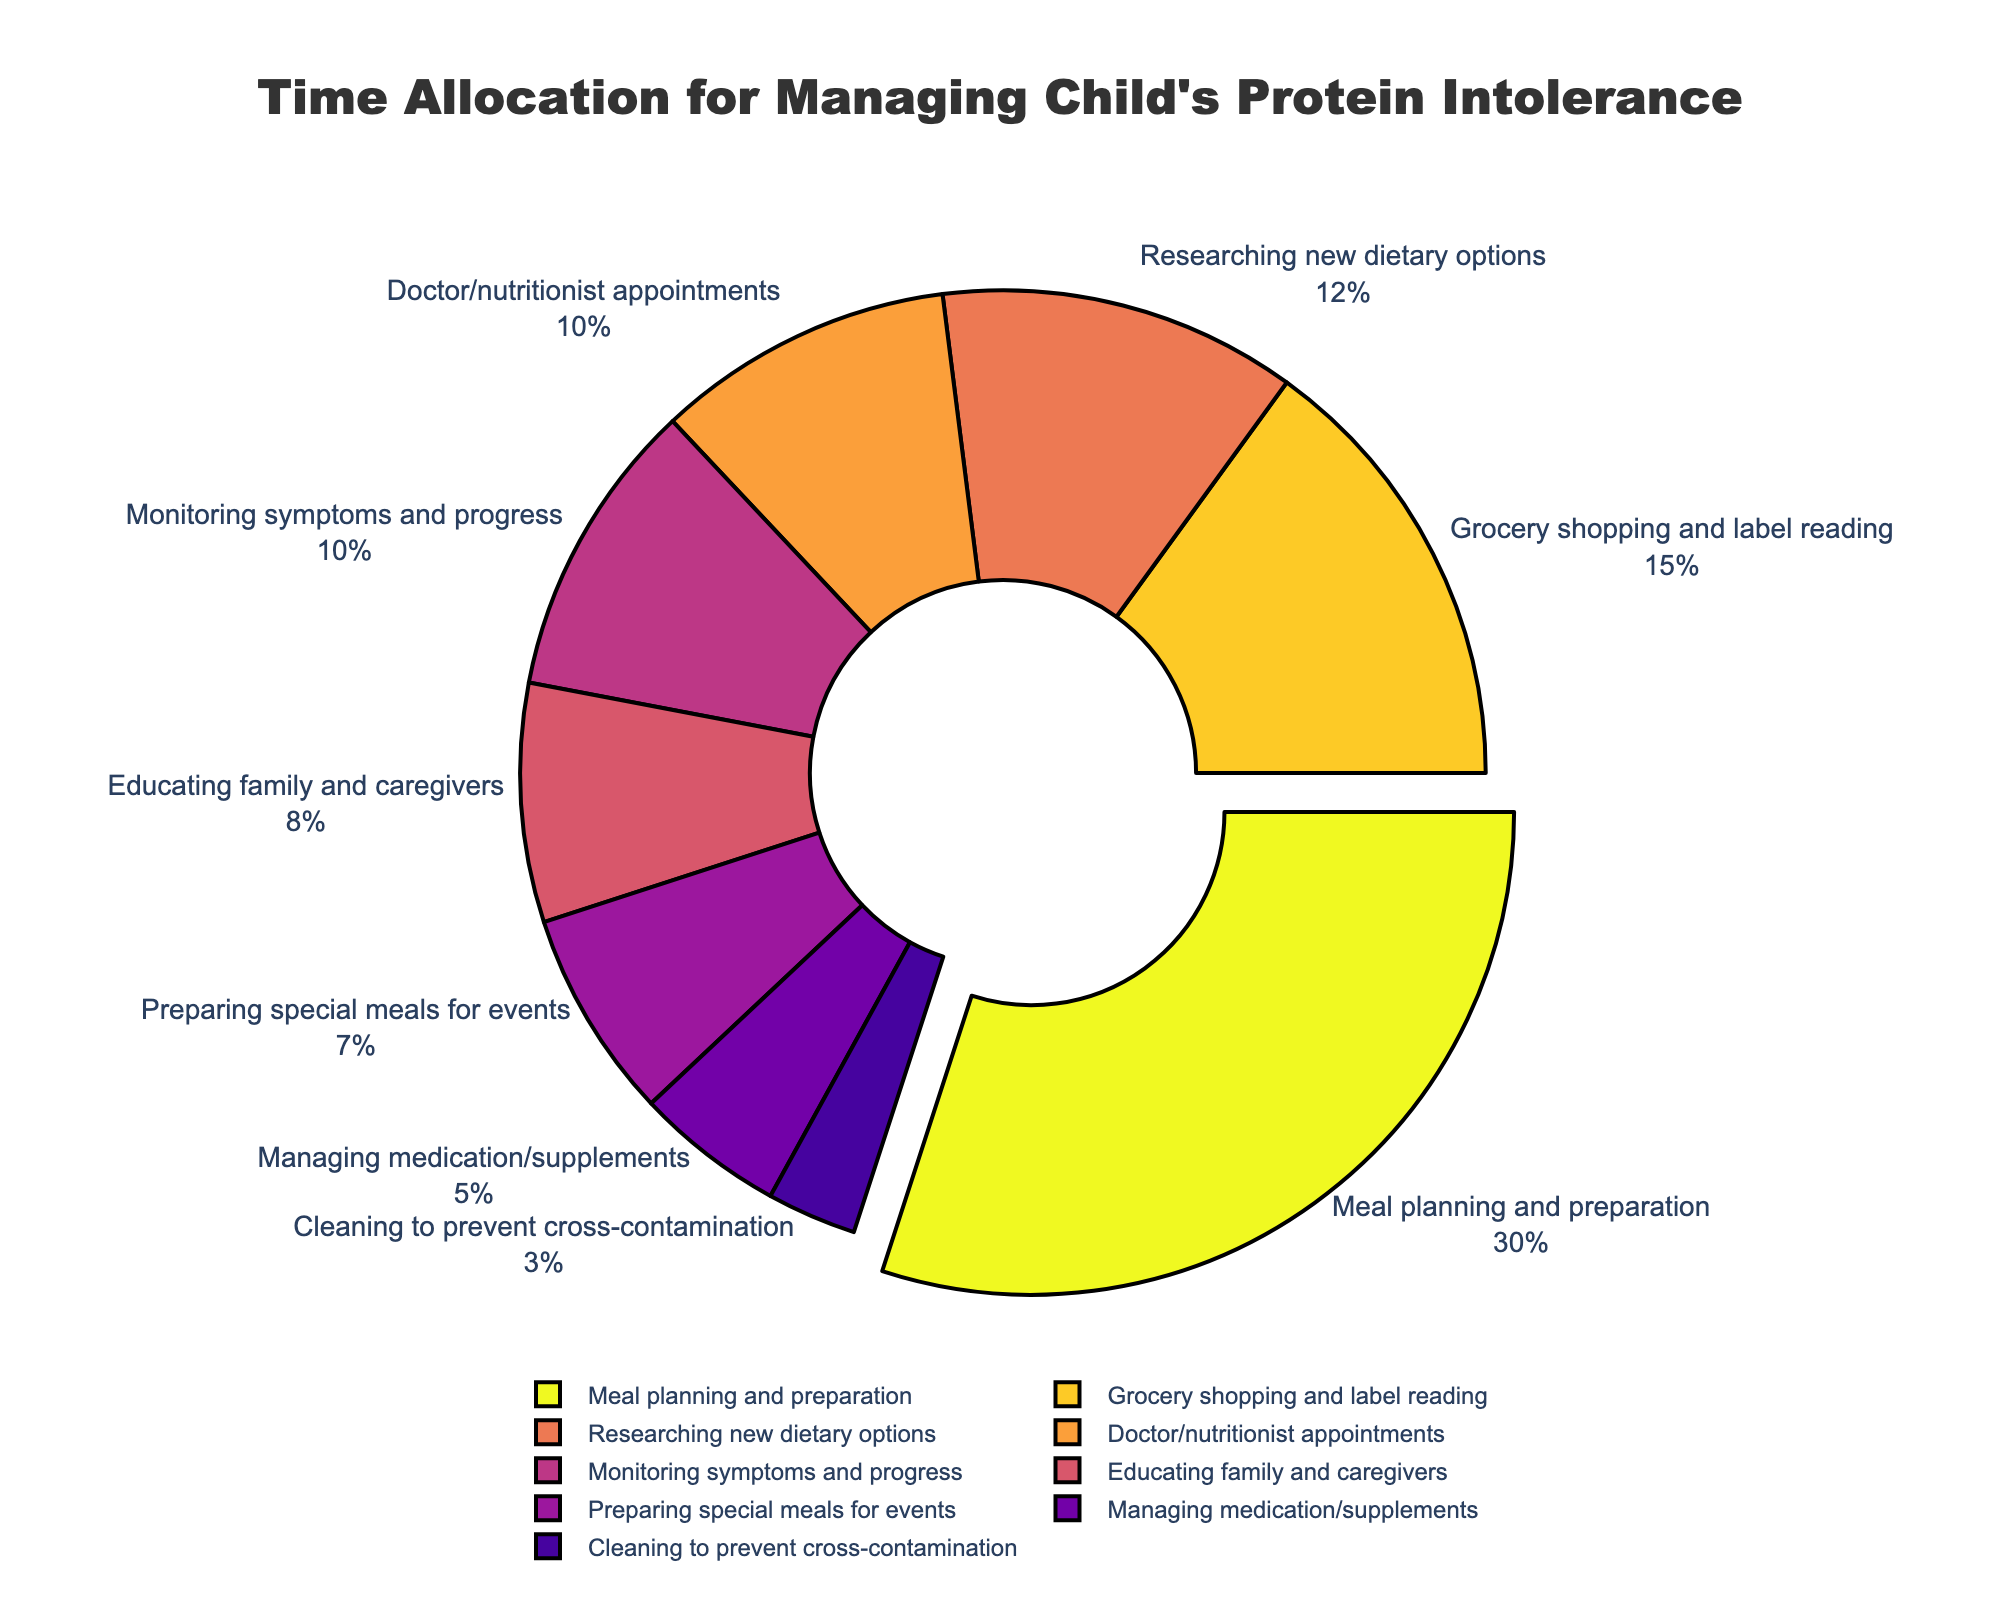What's the largest category in terms of time allocation? The segment with the largest percentage is "Meal planning and preparation" at 30%.
Answer: Meal planning and preparation Which activity takes the least amount of time? The segment with the smallest percentage is "Cleaning to prevent cross-contamination" at 3%.
Answer: Cleaning to prevent cross-contamination How much more time is spent on grocery shopping and label reading compared to managing medication/supplements? Grocery shopping and label reading takes 15% of the time, while managing medication/supplements takes 5%. The difference is 15% - 5% = 10%.
Answer: 10% What is the combined time allocation for researching new dietary options and monitoring symptoms and progress? Researching new dietary options takes 12%, and monitoring symptoms and progress takes 10%. Their combined total is 12% + 10% = 22%.
Answer: 22% Which categories together make up half of the total time allocation? Adding the percentages, "Meal planning and preparation" (30%) and "Grocery shopping and label reading" (15%) add up to 45%. Adding "Doctor/nutritionist appointments" (10%) gives 55%, which is over half. Therefore, "Meal planning and preparation" (30%) and "Grocery shopping and label reading" (15%) together make up 45%, which is just under half, so the next category added will surpass half.
Answer: Meal planning and preparation and Grocery shopping and label reading By observing the colors of the segments, which activity is represented by the darkest color? The colors of the segments are on a gradient scale, where darker colors represent lower percentages. The darkest color corresponds to "Cleaning to prevent cross-contamination" at 3%.
Answer: Cleaning to prevent cross-contamination Compare the proportions of time allocated to educating family and caregivers and preparing special meals for events. Educating family and caregivers takes 8%, and preparing special meals for events takes 7%. Educating family and caregivers (8%) is slightly more than preparing special meals for events (7%).
Answer: Educating family and caregivers more than preparing special meals for events What percentage of time is dedicated to activities related to food (meal planning, grocery shopping, and special meals for events)? Meal planning and preparation takes 30%, grocery shopping and label reading takes 15%, and preparing special meals for events takes 7%. Their combined total is 30% + 15% + 7% = 52%.
Answer: 52% Which activity is allocated exactly twice as much time as managing medication/supplements? Managing medication/supplements takes 5%. The activity allocated exactly twice that is 5% × 2 = 10%, which is Doctor/nutritionist appointments and Monitoring symptoms and progress, both at 10%.
Answer: Doctor/nutritionist appointments or Monitoring symptoms and progress 